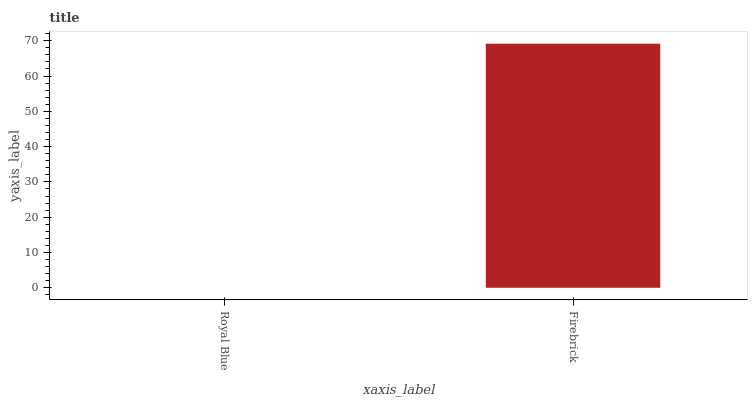Is Royal Blue the minimum?
Answer yes or no. Yes. Is Firebrick the maximum?
Answer yes or no. Yes. Is Firebrick the minimum?
Answer yes or no. No. Is Firebrick greater than Royal Blue?
Answer yes or no. Yes. Is Royal Blue less than Firebrick?
Answer yes or no. Yes. Is Royal Blue greater than Firebrick?
Answer yes or no. No. Is Firebrick less than Royal Blue?
Answer yes or no. No. Is Firebrick the high median?
Answer yes or no. Yes. Is Royal Blue the low median?
Answer yes or no. Yes. Is Royal Blue the high median?
Answer yes or no. No. Is Firebrick the low median?
Answer yes or no. No. 